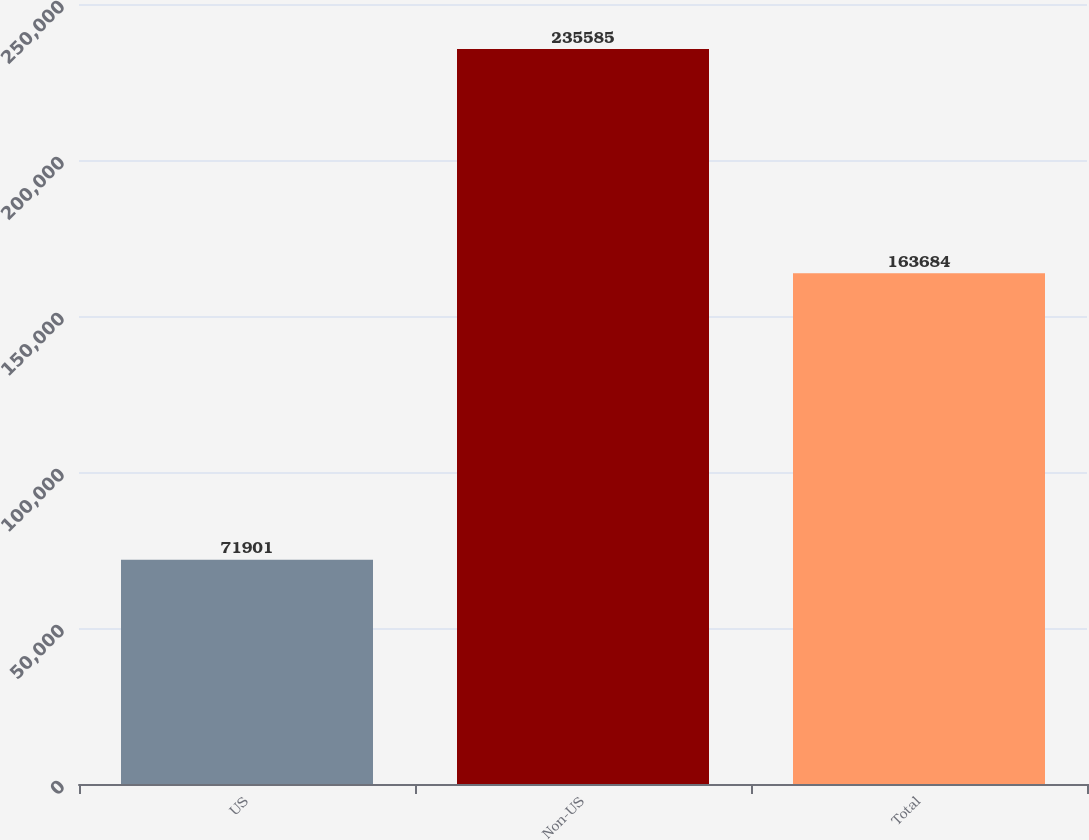Convert chart. <chart><loc_0><loc_0><loc_500><loc_500><bar_chart><fcel>US<fcel>Non-US<fcel>Total<nl><fcel>71901<fcel>235585<fcel>163684<nl></chart> 